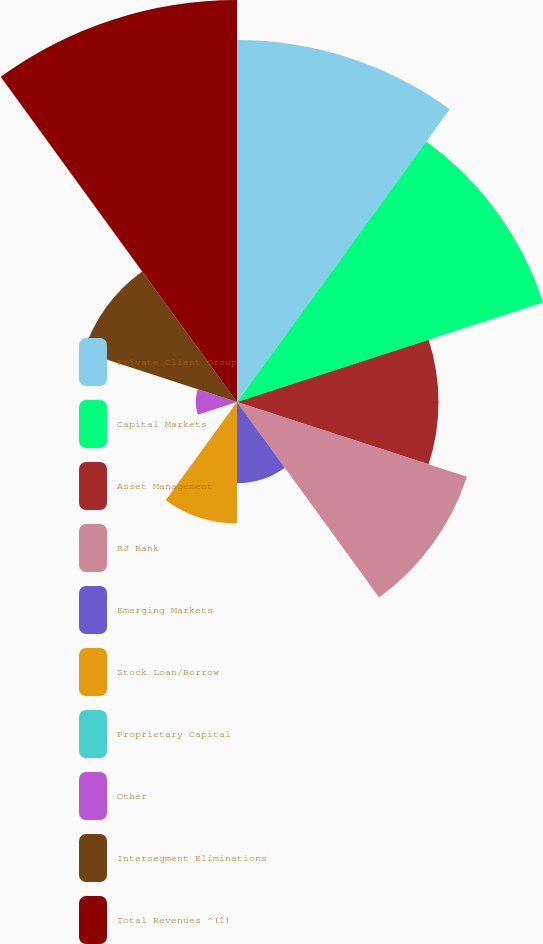Convert chart. <chart><loc_0><loc_0><loc_500><loc_500><pie_chart><fcel>Private Client Group<fcel>Capital Markets<fcel>Asset Management<fcel>RJ Bank<fcel>Emerging Markets<fcel>Stock Loan/Borrow<fcel>Proprietary Capital<fcel>Other<fcel>Intersegment Eliminations<fcel>Total Revenues ^(1)<nl><fcel>18.7%<fcel>16.63%<fcel>10.41%<fcel>12.49%<fcel>4.2%<fcel>6.27%<fcel>0.06%<fcel>2.13%<fcel>8.34%<fcel>20.77%<nl></chart> 